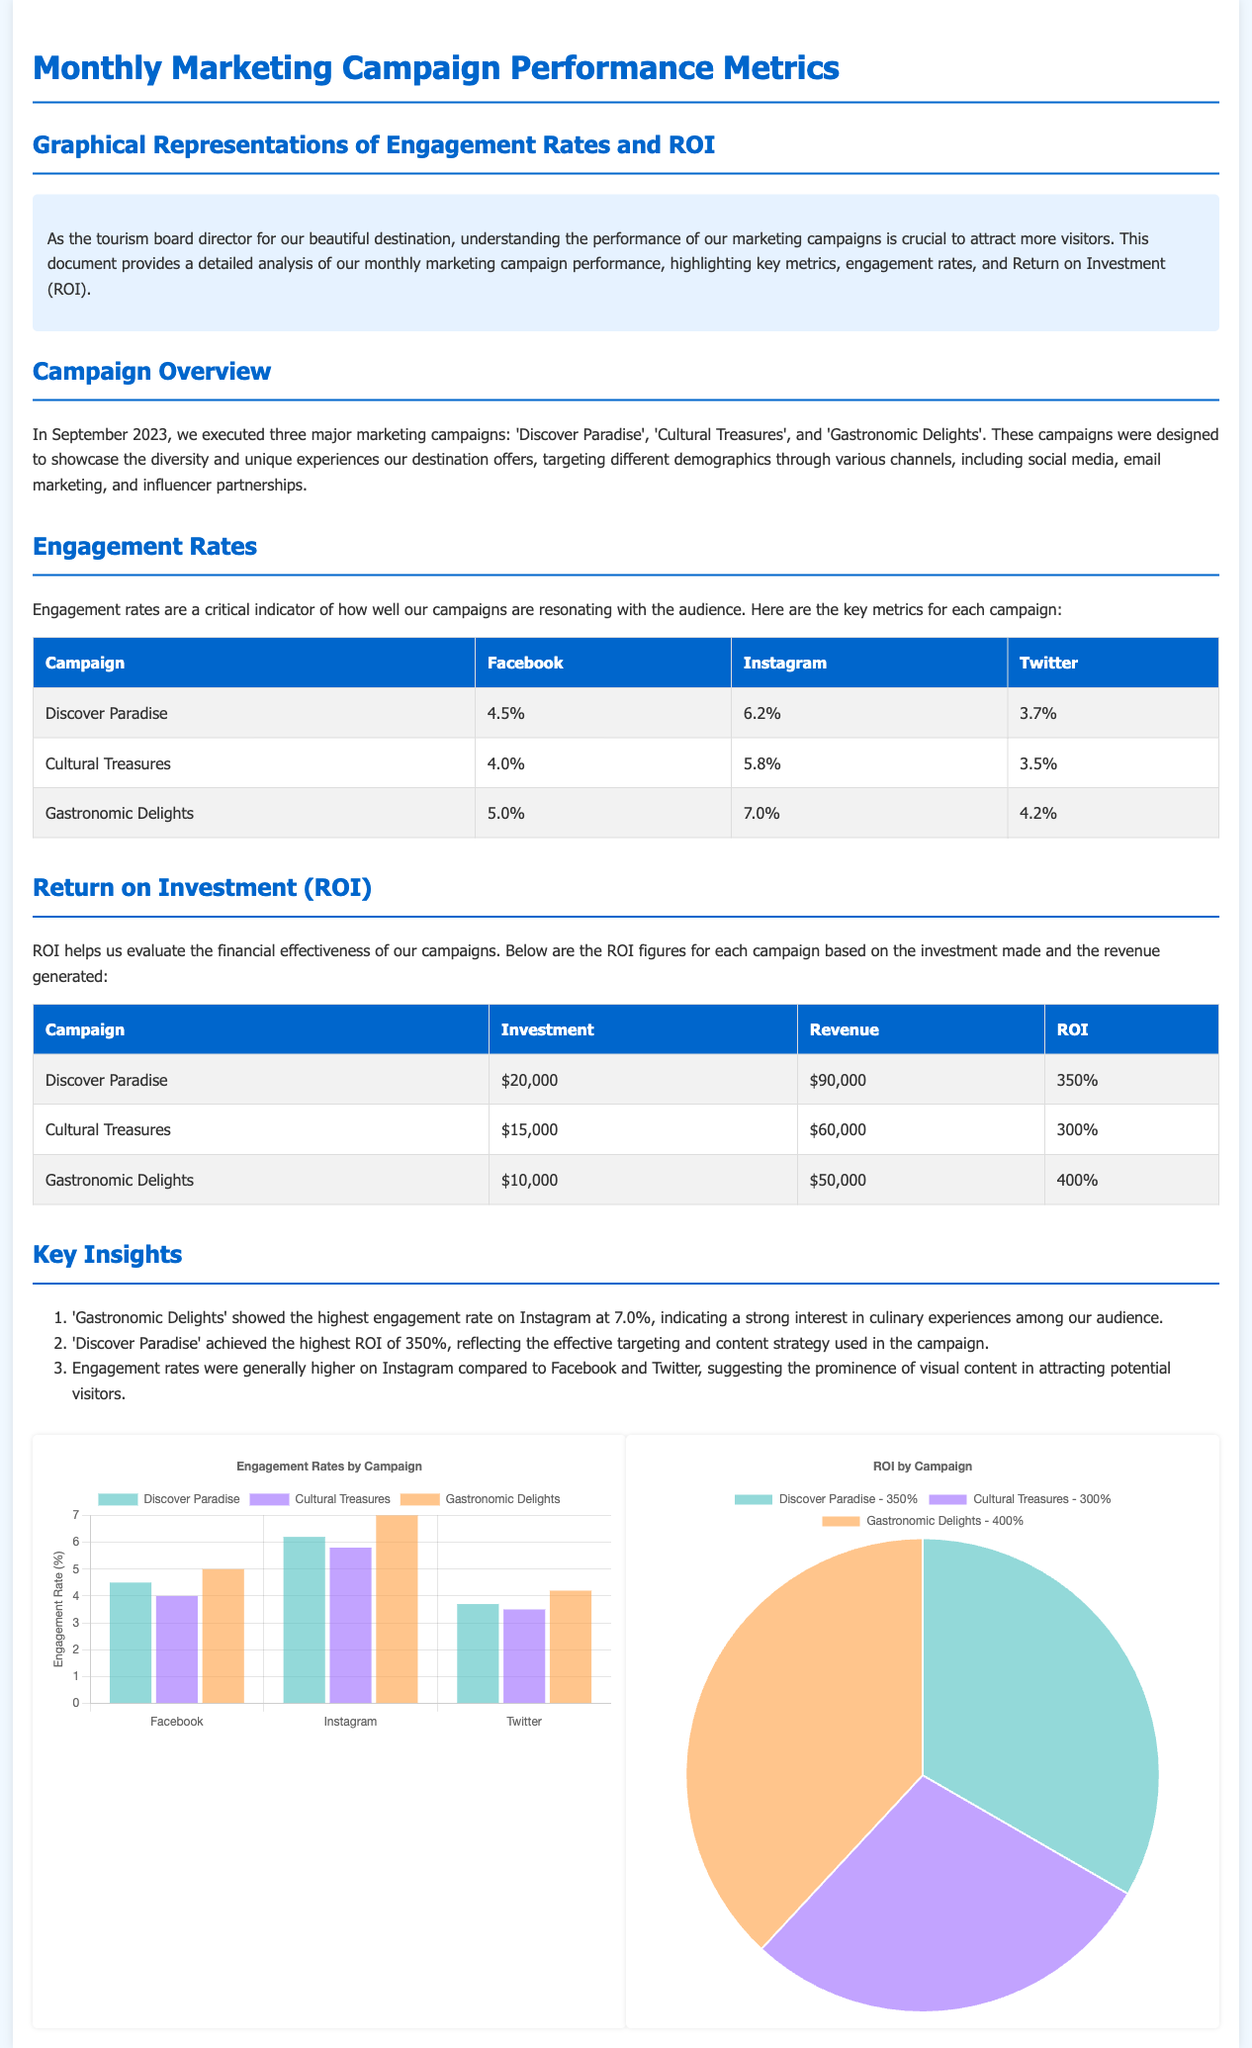What were the campaigns executed in September 2023? The campaigns executed in September 2023 are 'Discover Paradise', 'Cultural Treasures', and 'Gastronomic Delights'.
Answer: 'Discover Paradise', 'Cultural Treasures', 'Gastronomic Delights' Which campaign had the highest engagement rate on Instagram? The campaign with the highest engagement rate on Instagram was 'Gastronomic Delights' at 7.0%.
Answer: 7.0% What is the ROI of the 'Cultural Treasures' campaign? The ROI of the 'Cultural Treasures' campaign is calculated from the investment and revenue figures provided, which is 300%.
Answer: 300% Which social media platform showed lower engagement rates compared to Instagram? The social media platform that showed lower engagement rates compared to Instagram is Twitter as mentioned in the engagement rates table.
Answer: Twitter What was the total investment for all campaigns combined? The total investment for all campaigns is the sum of individual investments: $20,000 + $15,000 + $10,000 = $45,000.
Answer: $45,000 How much revenue did the 'Discover Paradise' campaign generate? The revenue generated by the 'Discover Paradise' campaign is stated as $90,000 in the ROI table.
Answer: $90,000 What does the engagement chart represent? The engagement chart represents the engagement rates by campaign across multiple social media platforms.
Answer: Engagement rates by campaign Which campaign had the lowest ROI? The campaign with the lowest ROI is 'Cultural Treasures' with an ROI of 300%.
Answer: Cultural Treasures What was the investment made for the 'Gastronomic Delights' campaign? The investment made for the 'Gastronomic Delights' campaign is specified as $10,000 in the ROI table.
Answer: $10,000 